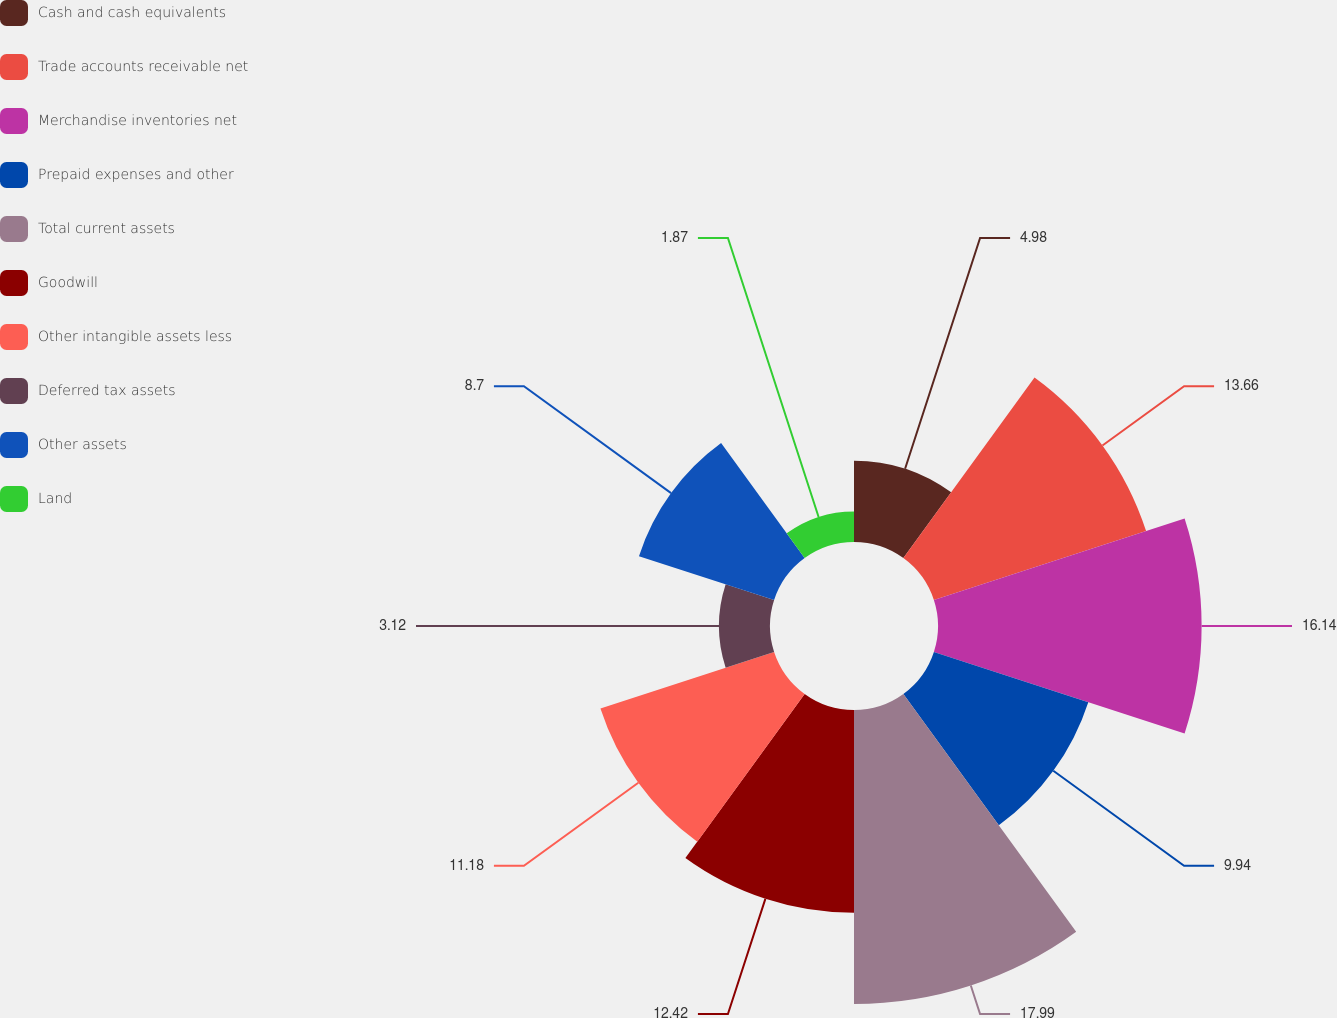Convert chart. <chart><loc_0><loc_0><loc_500><loc_500><pie_chart><fcel>Cash and cash equivalents<fcel>Trade accounts receivable net<fcel>Merchandise inventories net<fcel>Prepaid expenses and other<fcel>Total current assets<fcel>Goodwill<fcel>Other intangible assets less<fcel>Deferred tax assets<fcel>Other assets<fcel>Land<nl><fcel>4.98%<fcel>13.66%<fcel>16.14%<fcel>9.94%<fcel>18.0%<fcel>12.42%<fcel>11.18%<fcel>3.12%<fcel>8.7%<fcel>1.87%<nl></chart> 